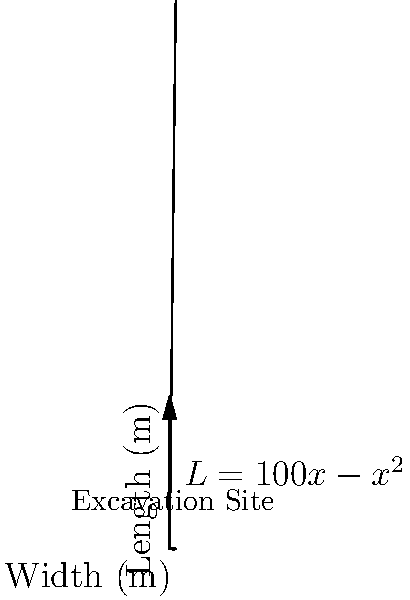Your archaeologist friend is planning a rectangular excavation site. The length (L) of the site in meters is given by the function $L = 100x - x^2$, where x is the width in meters. What dimensions should the excavation site have to maximize its area, and what is the maximum area? Let's approach this step-by-step:

1) The area (A) of a rectangle is given by length times width. So:
   $A = L * x = (100x - x^2) * x = 100x^2 - x^3$

2) To find the maximum area, we need to find where the derivative of A with respect to x equals zero:
   $\frac{dA}{dx} = 200x - 3x^2$

3) Set this equal to zero:
   $200x - 3x^2 = 0$

4) Factor out x:
   $x(200 - 3x) = 0$

5) Solve for x:
   $x = 0$ or $200 - 3x = 0$
   $x = 0$ or $x = \frac{200}{3} \approx 66.67$

6) The width can't be 0, so $x = \frac{200}{3}$ meters is our optimal width.

7) To find the length, plug this value back into the original equation:
   $L = 100(\frac{200}{3}) - (\frac{200}{3})^2 = \frac{20000}{3} - \frac{40000}{9} = \frac{60000}{9} - \frac{40000}{9} = \frac{20000}{9} \approx 2222.22$ meters

8) The maximum area is:
   $A = \frac{200}{3} * \frac{20000}{9} = \frac{4000000}{27} \approx 148148.15$ square meters

Therefore, the optimal dimensions are approximately 66.67 meters wide by 2222.22 meters long, with a maximum area of about 148148.15 square meters.
Answer: Width: $\frac{200}{3}$ m, Length: $\frac{20000}{9}$ m, Maximum Area: $\frac{4000000}{27}$ m² 